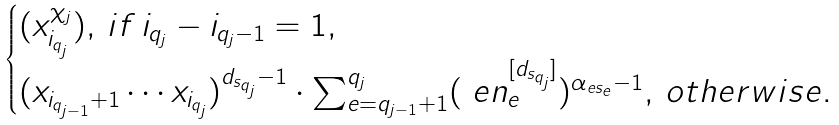<formula> <loc_0><loc_0><loc_500><loc_500>\begin{cases} ( x _ { i _ { q _ { j } } } ^ { \chi _ { j } } ) , \, i f \, i _ { q _ { j } } - i _ { q _ { j } - 1 } = 1 , \\ ( x _ { i _ { q _ { j - 1 } } + 1 } \cdots x _ { i _ { q _ { j } } } ) ^ { d _ { s _ { q _ { j } } } - 1 } \cdot \sum _ { e = q _ { j - 1 } + 1 } ^ { q _ { j } } ( \ e n _ { e } ^ { [ d _ { s _ { q _ { j } } } ] } ) ^ { \alpha _ { e s _ { e } } - 1 } , \, o t h e r w i s e . \end{cases}</formula> 